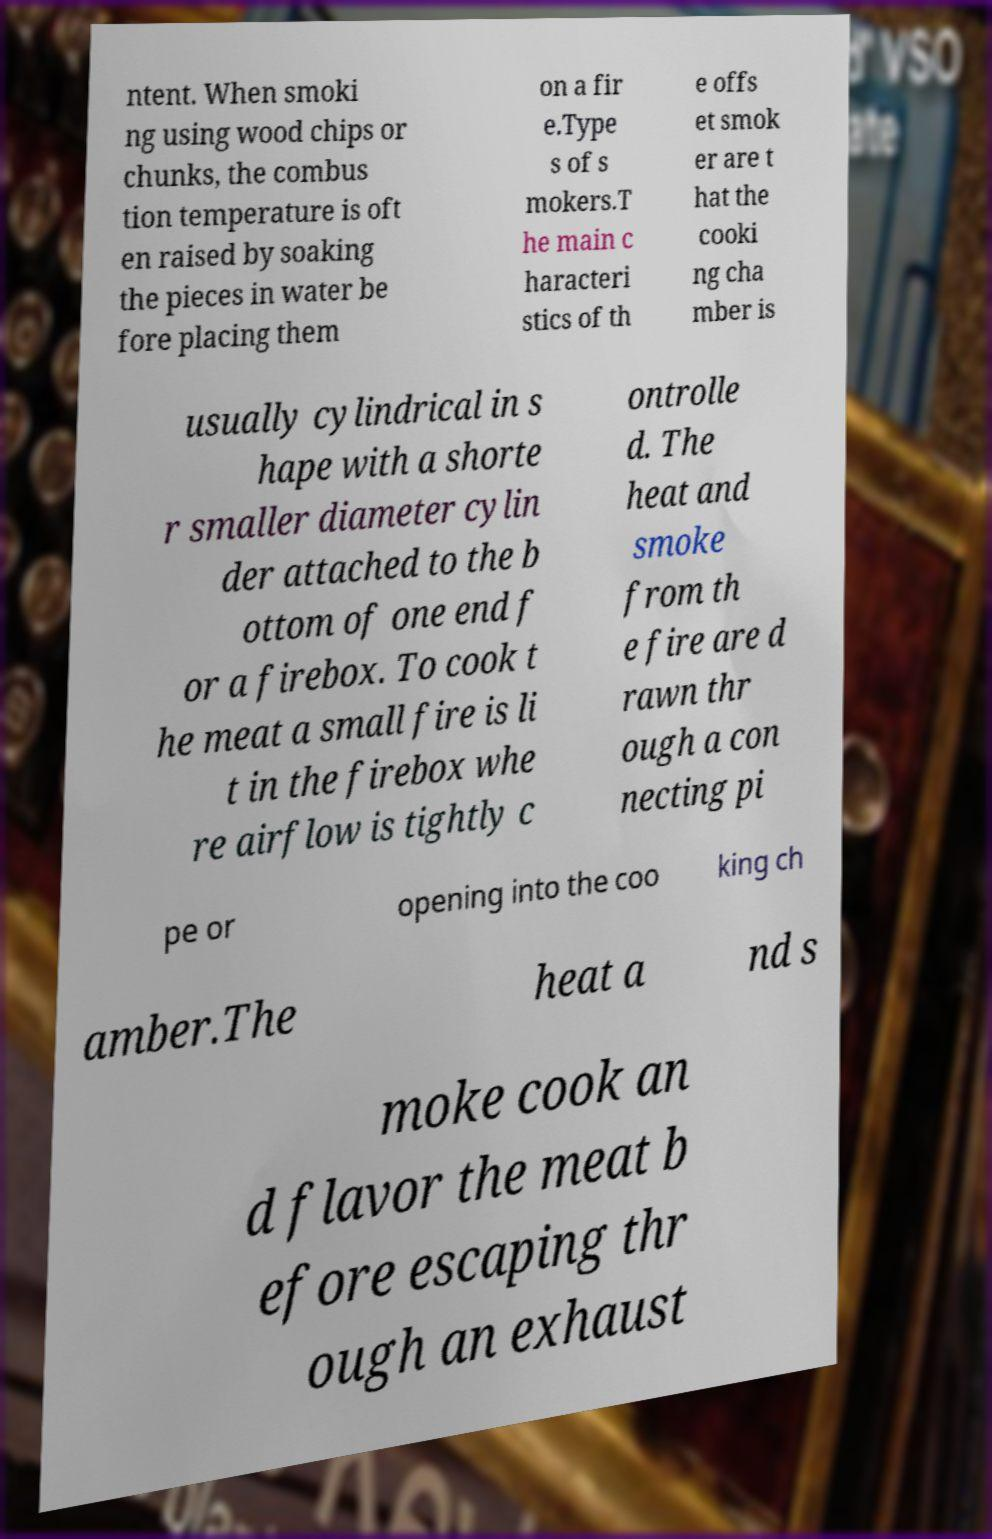Could you extract and type out the text from this image? ntent. When smoki ng using wood chips or chunks, the combus tion temperature is oft en raised by soaking the pieces in water be fore placing them on a fir e.Type s of s mokers.T he main c haracteri stics of th e offs et smok er are t hat the cooki ng cha mber is usually cylindrical in s hape with a shorte r smaller diameter cylin der attached to the b ottom of one end f or a firebox. To cook t he meat a small fire is li t in the firebox whe re airflow is tightly c ontrolle d. The heat and smoke from th e fire are d rawn thr ough a con necting pi pe or opening into the coo king ch amber.The heat a nd s moke cook an d flavor the meat b efore escaping thr ough an exhaust 